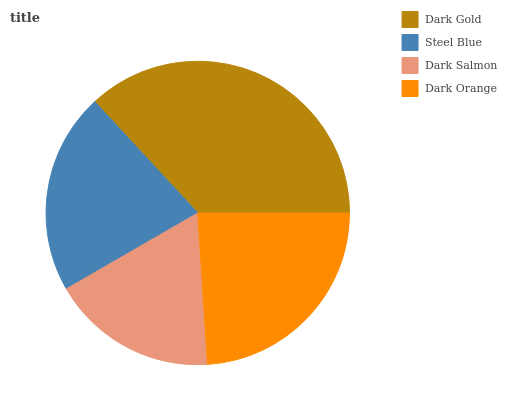Is Dark Salmon the minimum?
Answer yes or no. Yes. Is Dark Gold the maximum?
Answer yes or no. Yes. Is Steel Blue the minimum?
Answer yes or no. No. Is Steel Blue the maximum?
Answer yes or no. No. Is Dark Gold greater than Steel Blue?
Answer yes or no. Yes. Is Steel Blue less than Dark Gold?
Answer yes or no. Yes. Is Steel Blue greater than Dark Gold?
Answer yes or no. No. Is Dark Gold less than Steel Blue?
Answer yes or no. No. Is Dark Orange the high median?
Answer yes or no. Yes. Is Steel Blue the low median?
Answer yes or no. Yes. Is Dark Salmon the high median?
Answer yes or no. No. Is Dark Salmon the low median?
Answer yes or no. No. 